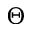<formula> <loc_0><loc_0><loc_500><loc_500>\Theta</formula> 